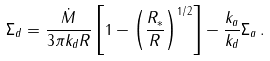<formula> <loc_0><loc_0><loc_500><loc_500>\Sigma _ { d } = \frac { \dot { M } } { 3 \pi k _ { d } R } \left [ 1 - \left ( \frac { R _ { * } } { R } \right ) ^ { 1 / 2 } \right ] - \frac { k _ { a } } { k _ { d } } \Sigma _ { a } \, .</formula> 